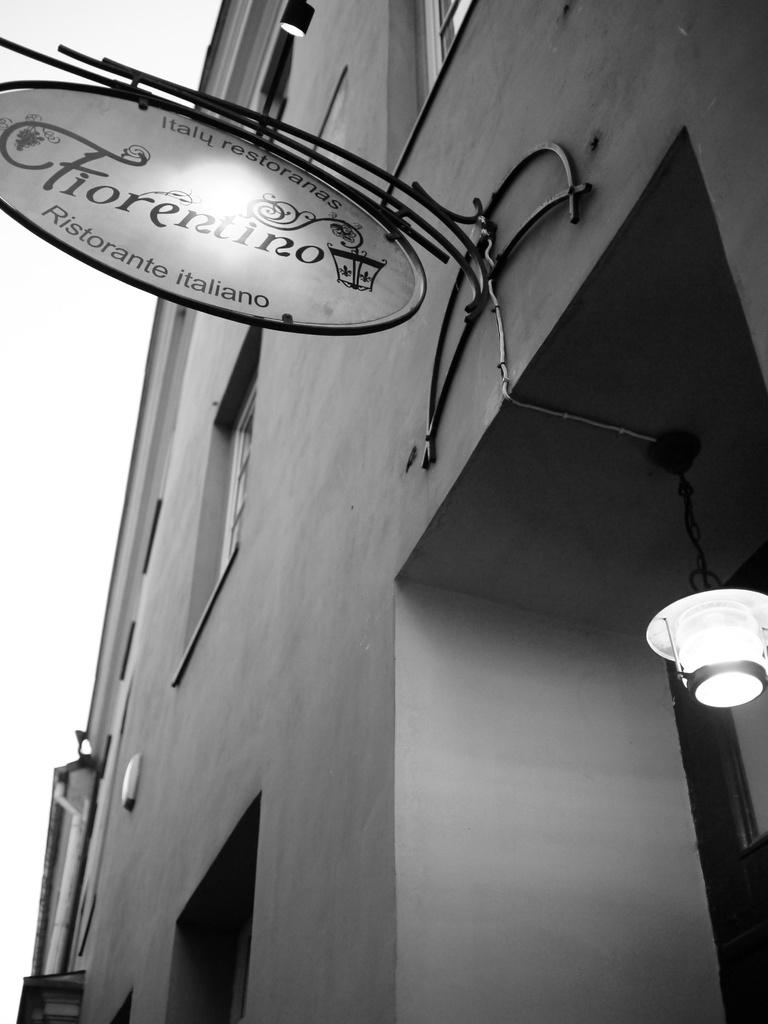What type of structure is visible in the image? There is a building in the image. Can you describe the lighting in the image? There is a light on the right side of the image. What is attached to the building? There is a board on the building. How many babies are present in the image? There are no babies present in the image. What type of insurance is being advertised on the board? There is no information about insurance in the image, as it only features a building, a light, and a board. 